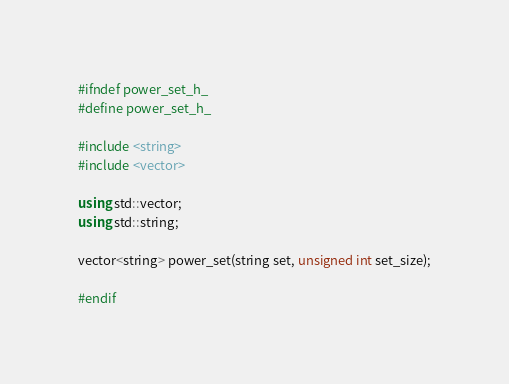Convert code to text. <code><loc_0><loc_0><loc_500><loc_500><_C++_>#ifndef power_set_h_
#define power_set_h_

#include <string>
#include <vector>

using std::vector;
using std::string;

vector<string> power_set(string set, unsigned int set_size);

#endif
</code> 